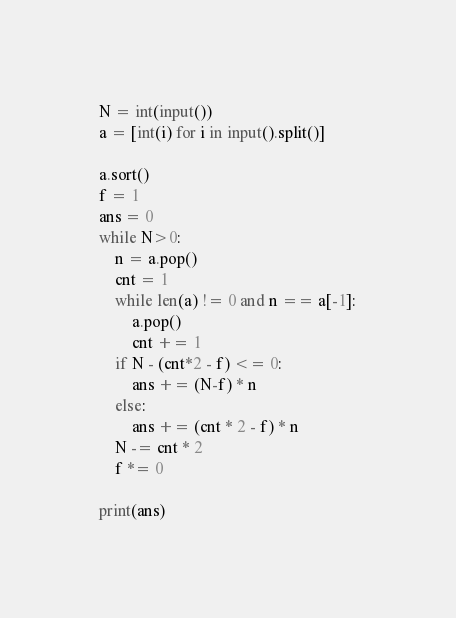<code> <loc_0><loc_0><loc_500><loc_500><_Python_>N = int(input())
a = [int(i) for i in input().split()]

a.sort()
f = 1
ans = 0
while N>0:
    n = a.pop()
    cnt = 1
    while len(a) != 0 and n == a[-1]:
        a.pop()
        cnt += 1
    if N - (cnt*2 - f) <= 0:
        ans += (N-f) * n
    else:
        ans += (cnt * 2 - f) * n
    N -= cnt * 2 
    f *= 0

print(ans)</code> 